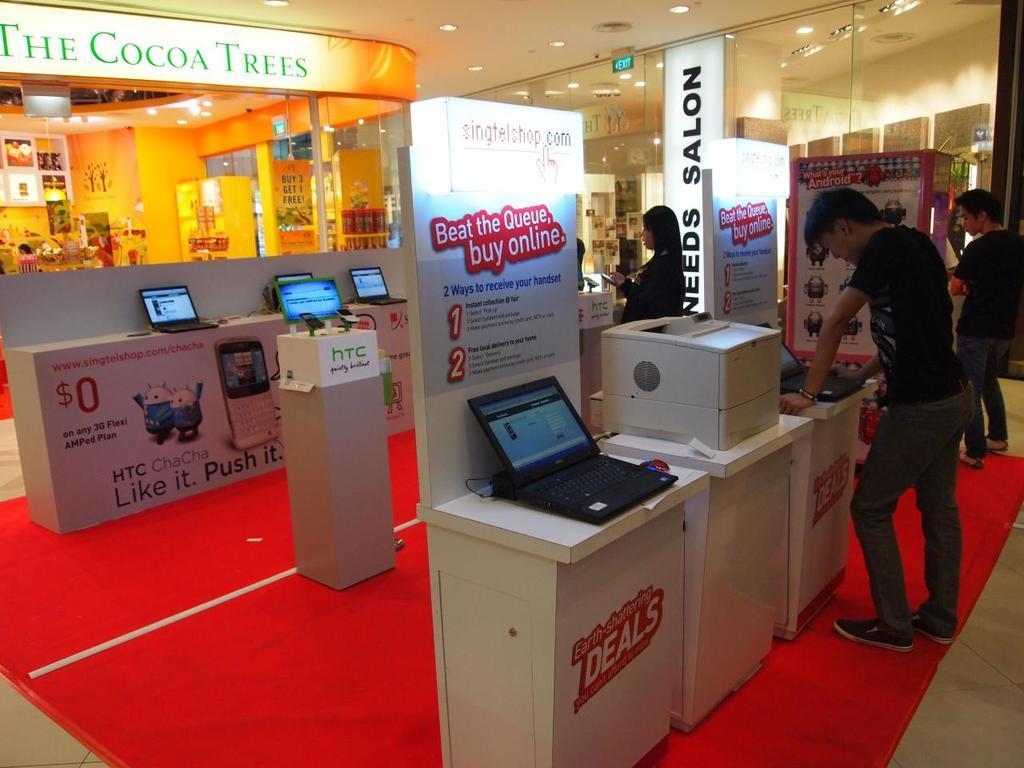Could you give a brief overview of what you see in this image? In this picture we can see few people, laptops, mobiles and hoardings, in the background we can find few lights, also we can see text on the hoardings. 